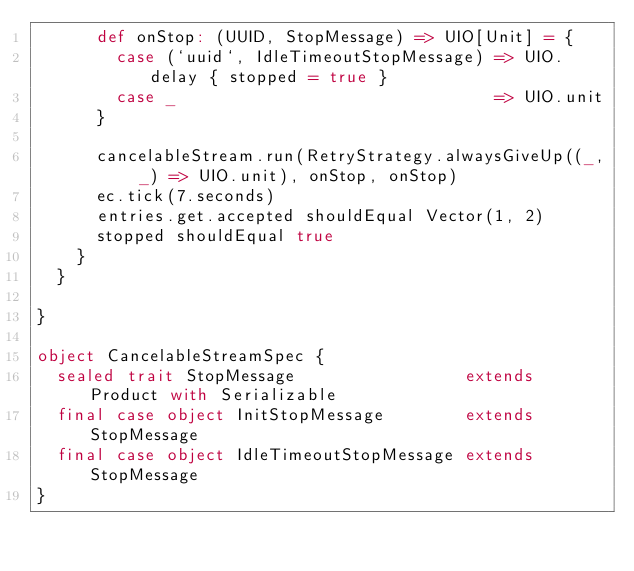<code> <loc_0><loc_0><loc_500><loc_500><_Scala_>      def onStop: (UUID, StopMessage) => UIO[Unit] = {
        case (`uuid`, IdleTimeoutStopMessage) => UIO.delay { stopped = true }
        case _                                => UIO.unit
      }

      cancelableStream.run(RetryStrategy.alwaysGiveUp((_, _) => UIO.unit), onStop, onStop)
      ec.tick(7.seconds)
      entries.get.accepted shouldEqual Vector(1, 2)
      stopped shouldEqual true
    }
  }

}

object CancelableStreamSpec {
  sealed trait StopMessage                 extends Product with Serializable
  final case object InitStopMessage        extends StopMessage
  final case object IdleTimeoutStopMessage extends StopMessage
}
</code> 